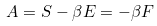<formula> <loc_0><loc_0><loc_500><loc_500>A = S - \beta E = - \beta F</formula> 